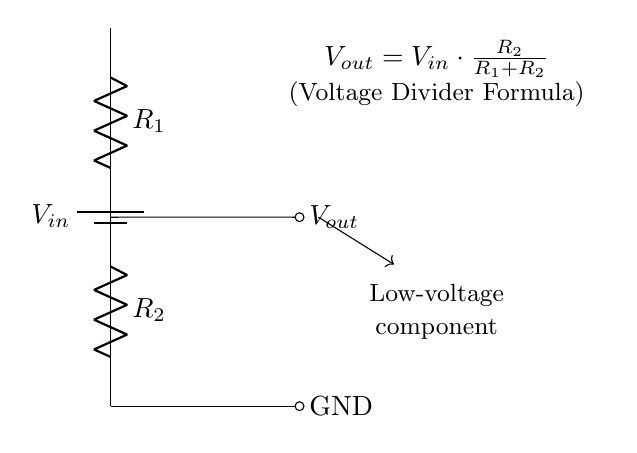What is the function of the resistors in this circuit? The resistors R1 and R2 create a voltage divider that reduces the input voltage, allowing a lower voltage output, which is necessary for powering low-voltage components.
Answer: Voltage divider What is the voltage at the output node? The output voltage is calculated using the voltage divider formula: Vout = Vin * (R2 / (R1 + R2)). This formula shows that Vout is a fraction of the input voltage dependent on the values of resistors R1 and R2.
Answer: Vout = Vin * (R2 / (R1 + R2)) How many resistors are in the circuit? There are two resistors, R1 and R2, shown in the diagram connected in series.
Answer: Two What would happen if R2 is much larger than R1? If R2 is much larger than R1, the output voltage Vout will approach the input voltage Vout ≈ Vin, because more of the voltage drops across R2.
Answer: Vout approaches Vin What does GND refer to in the circuit? GND refers to the ground node, which is the reference point for voltage measurements and provides a common return path for current in the circuit.
Answer: Ground If the input voltage is 10 volts and R1 is 1k ohm while R2 is 3k ohms, what is Vout? Using the voltage divider formula, Vout = Vin * (R2 / (R1 + R2)) = 10 * (3000 / (1000 + 3000)) = 7.5 volts. This shows how the specific values of R1 and R2 directly influence the final output voltage.
Answer: 7.5 volts 